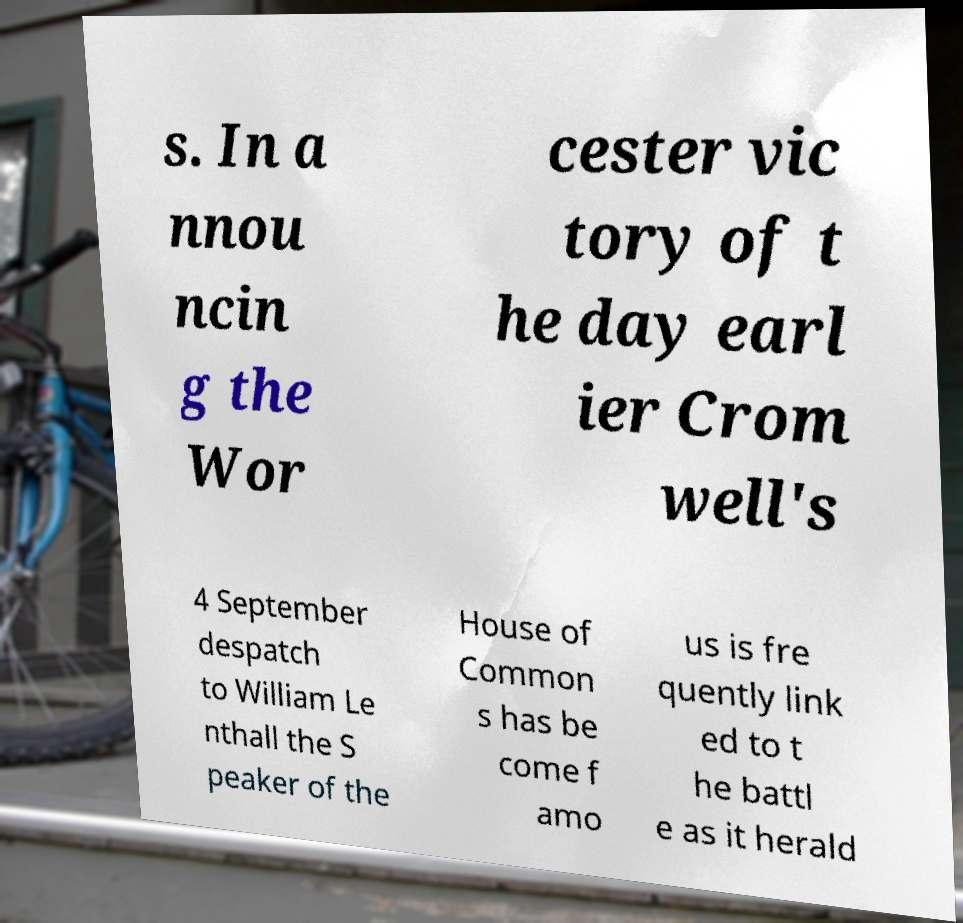For documentation purposes, I need the text within this image transcribed. Could you provide that? s. In a nnou ncin g the Wor cester vic tory of t he day earl ier Crom well's 4 September despatch to William Le nthall the S peaker of the House of Common s has be come f amo us is fre quently link ed to t he battl e as it herald 